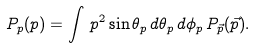Convert formula to latex. <formula><loc_0><loc_0><loc_500><loc_500>P _ { p } ( p ) = \int \, p ^ { 2 } \sin \theta _ { p } \, d \theta _ { p } \, d \phi _ { p } \, P _ { \vec { p } } ( \vec { p } ) .</formula> 